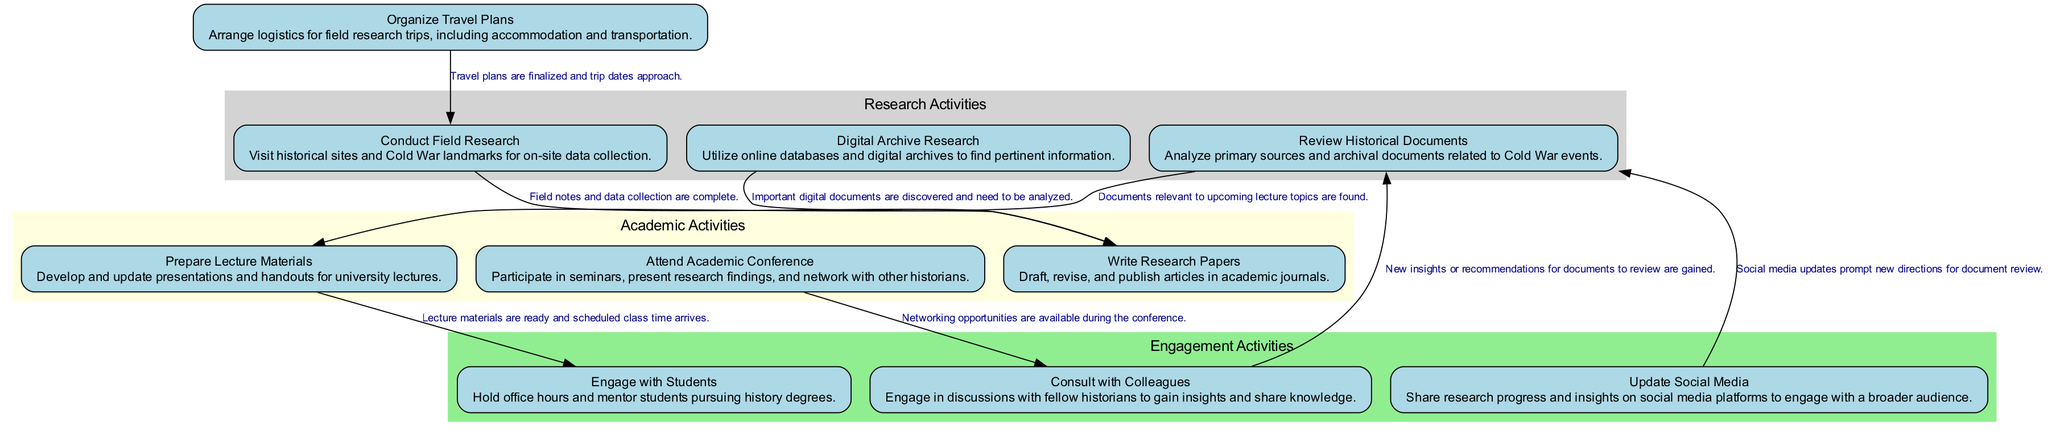What is the first activity represented in the diagram? The first activity in the diagram is the node labeled "Review Historical Documents". This can be identified as it's typically located at the top or the beginning of the flow in an activity diagram.
Answer: Review Historical Documents How many activities are depicted in the diagram? By counting the individual nodes listed for activities, we can determine that there are a total of ten distinct activities represented in the diagram.
Answer: 10 What activity follows "Update Social Media" in the diagram? The transition from "Update Social Media" leads back to "Review Historical Documents". This can be verified by following the edge connecting these two nodes.
Answer: Review Historical Documents What is the condition for transitioning from "Conduct Field Research" to "Write Research Papers"? The specified condition for this transition is that field notes and data collection need to be complete, as indicated on the directed edge between these activities.
Answer: Field notes and data collection are complete Which activities require consultation with colleagues? The activities that require consulting with colleagues are "Attend Academic Conference" and "Consult with Colleagues" itself, as seen in the edges originating from the "Attend Academic Conference" node.
Answer: Attend Academic Conference, Consult with Colleagues What role do "Digital Archive Research" and "Review Historical Documents" play in the diagram? Both activities are identified as critical research activities, with "Digital Archive Research" leading to "Write Research Papers", and "Review Historical Documents" initiated at the beginning of research.
Answer: Research activities How many edges connect the activity "Prepare Lecture Materials"? The activity "Prepare Lecture Materials" connects to "Engage with Students" with one edge leading toward it, meaning there is just one direct connection from this activity to another.
Answer: 1 What is the final activity after "Attend Academic Conference"? The activity that follows "Attend Academic Conference" is "Consult with Colleagues" as indicated by the directed edge pointing to this node from the previous one.
Answer: Consult with Colleagues Identify two activities related to field research. The activities that relate directly to field research are "Conduct Field Research" and "Organize Travel Plans", as both are concerned with the logistics and execution of fieldwork.
Answer: Conduct Field Research, Organize Travel Plans 